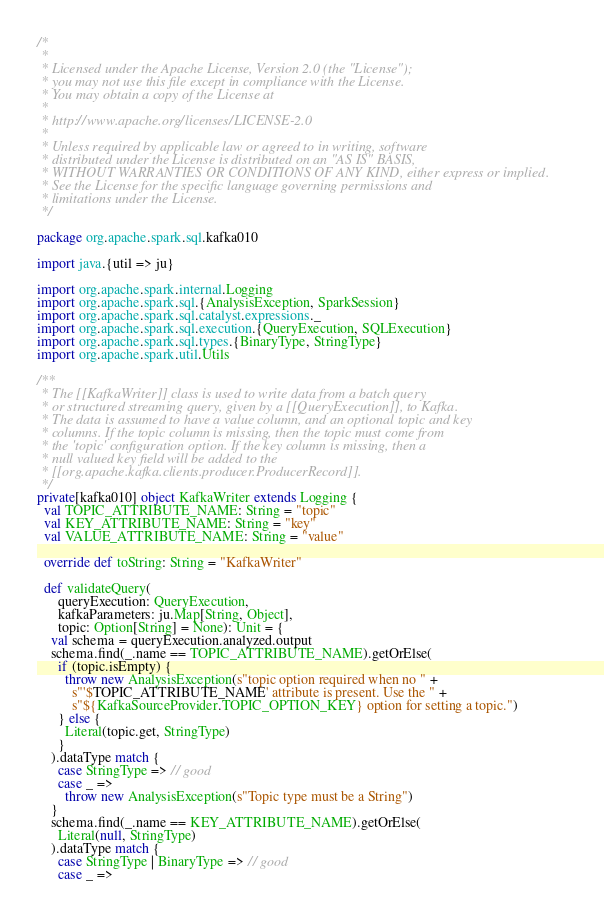<code> <loc_0><loc_0><loc_500><loc_500><_Scala_>/*
 *
 * Licensed under the Apache License, Version 2.0 (the "License");
 * you may not use this file except in compliance with the License.
 * You may obtain a copy of the License at
 *
 * http://www.apache.org/licenses/LICENSE-2.0
 *
 * Unless required by applicable law or agreed to in writing, software
 * distributed under the License is distributed on an "AS IS" BASIS,
 * WITHOUT WARRANTIES OR CONDITIONS OF ANY KIND, either express or implied.
 * See the License for the specific language governing permissions and
 * limitations under the License.
 */

package org.apache.spark.sql.kafka010

import java.{util => ju}

import org.apache.spark.internal.Logging
import org.apache.spark.sql.{AnalysisException, SparkSession}
import org.apache.spark.sql.catalyst.expressions._
import org.apache.spark.sql.execution.{QueryExecution, SQLExecution}
import org.apache.spark.sql.types.{BinaryType, StringType}
import org.apache.spark.util.Utils

/**
 * The [[KafkaWriter]] class is used to write data from a batch query
 * or structured streaming query, given by a [[QueryExecution]], to Kafka.
 * The data is assumed to have a value column, and an optional topic and key
 * columns. If the topic column is missing, then the topic must come from
 * the 'topic' configuration option. If the key column is missing, then a
 * null valued key field will be added to the
 * [[org.apache.kafka.clients.producer.ProducerRecord]].
 */
private[kafka010] object KafkaWriter extends Logging {
  val TOPIC_ATTRIBUTE_NAME: String = "topic"
  val KEY_ATTRIBUTE_NAME: String = "key"
  val VALUE_ATTRIBUTE_NAME: String = "value"

  override def toString: String = "KafkaWriter"

  def validateQuery(
      queryExecution: QueryExecution,
      kafkaParameters: ju.Map[String, Object],
      topic: Option[String] = None): Unit = {
    val schema = queryExecution.analyzed.output
    schema.find(_.name == TOPIC_ATTRIBUTE_NAME).getOrElse(
      if (topic.isEmpty) {
        throw new AnalysisException(s"topic option required when no " +
          s"'$TOPIC_ATTRIBUTE_NAME' attribute is present. Use the " +
          s"${KafkaSourceProvider.TOPIC_OPTION_KEY} option for setting a topic.")
      } else {
        Literal(topic.get, StringType)
      }
    ).dataType match {
      case StringType => // good
      case _ =>
        throw new AnalysisException(s"Topic type must be a String")
    }
    schema.find(_.name == KEY_ATTRIBUTE_NAME).getOrElse(
      Literal(null, StringType)
    ).dataType match {
      case StringType | BinaryType => // good
      case _ =></code> 